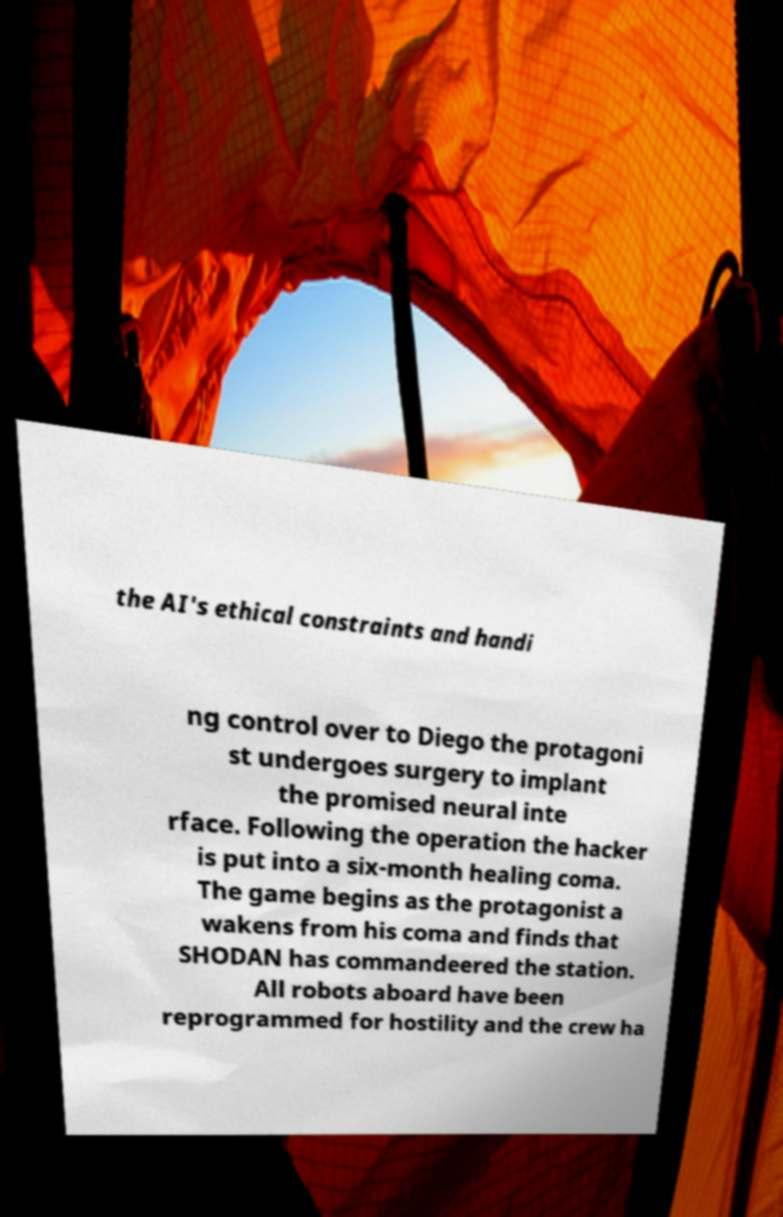Please read and relay the text visible in this image. What does it say? the AI's ethical constraints and handi ng control over to Diego the protagoni st undergoes surgery to implant the promised neural inte rface. Following the operation the hacker is put into a six-month healing coma. The game begins as the protagonist a wakens from his coma and finds that SHODAN has commandeered the station. All robots aboard have been reprogrammed for hostility and the crew ha 